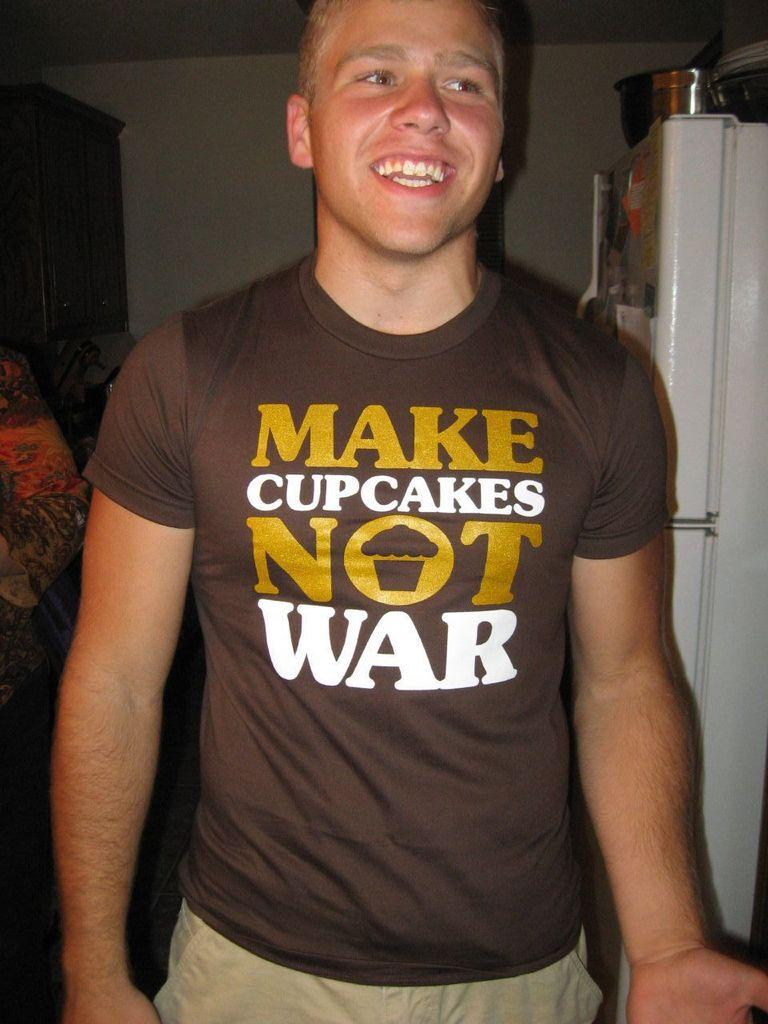<image>
Write a terse but informative summary of the picture. a man with brown colored t shirt with printing as Make cupcakes not war 